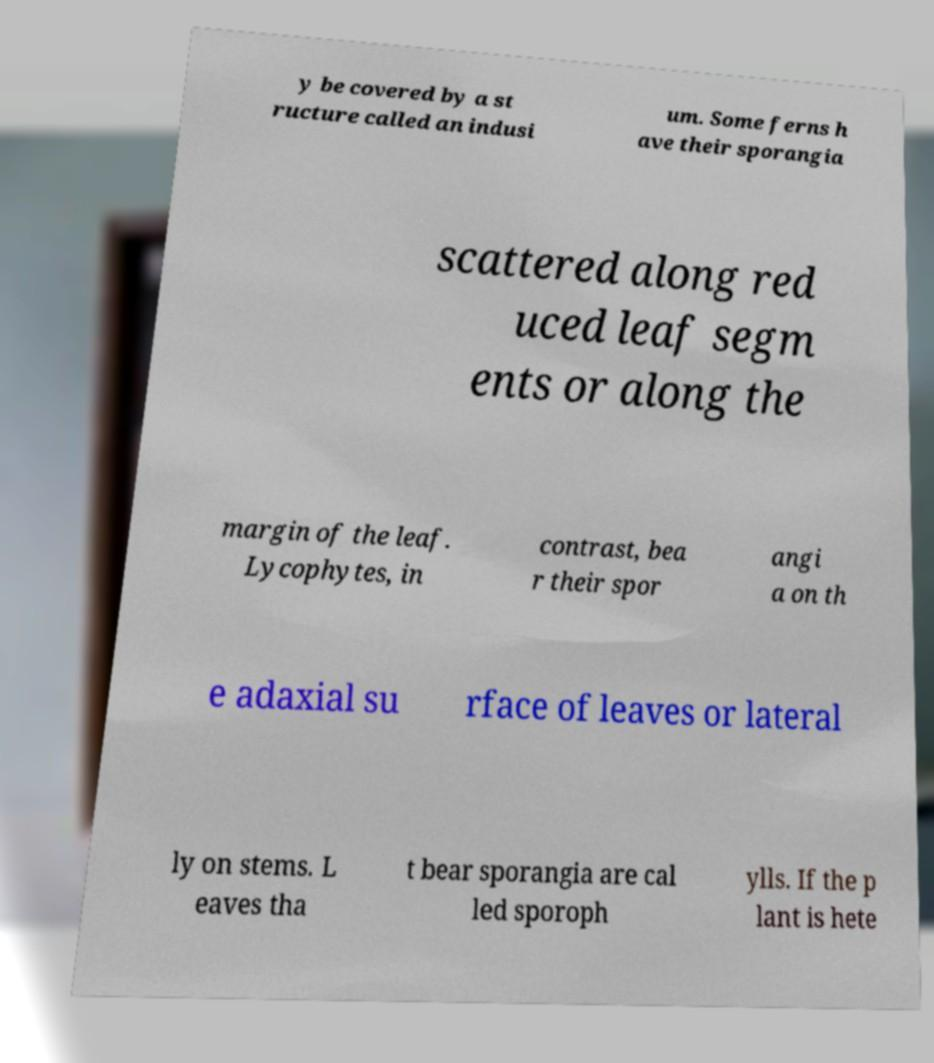What messages or text are displayed in this image? I need them in a readable, typed format. y be covered by a st ructure called an indusi um. Some ferns h ave their sporangia scattered along red uced leaf segm ents or along the margin of the leaf. Lycophytes, in contrast, bea r their spor angi a on th e adaxial su rface of leaves or lateral ly on stems. L eaves tha t bear sporangia are cal led sporoph ylls. If the p lant is hete 